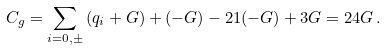Convert formula to latex. <formula><loc_0><loc_0><loc_500><loc_500>C _ { g } = \sum _ { i = 0 , \pm } \left ( q _ { i } + G \right ) + ( - G ) - 2 1 ( - G ) + 3 G = 2 4 G \, .</formula> 